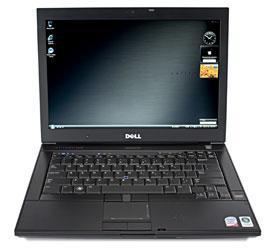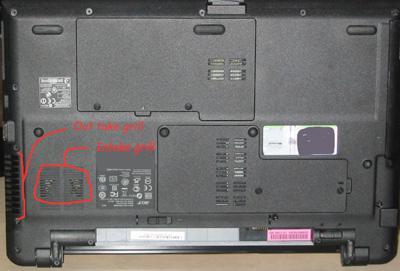The first image is the image on the left, the second image is the image on the right. For the images shown, is this caption "The left image shows laptops in horizontal rows of three and includes rows of open laptops and rows of closed laptops." true? Answer yes or no. No. The first image is the image on the left, the second image is the image on the right. For the images displayed, is the sentence "There are exactly five open laptops." factually correct? Answer yes or no. No. 